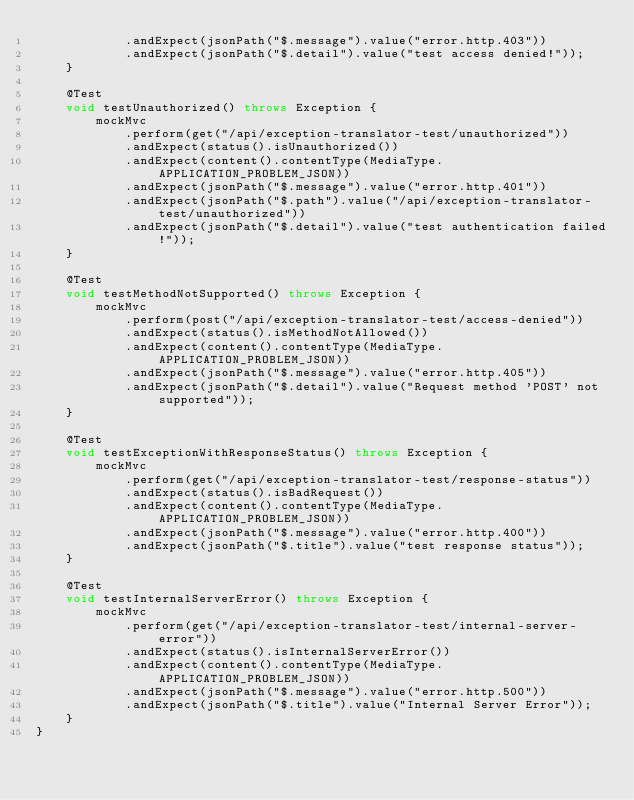Convert code to text. <code><loc_0><loc_0><loc_500><loc_500><_Java_>            .andExpect(jsonPath("$.message").value("error.http.403"))
            .andExpect(jsonPath("$.detail").value("test access denied!"));
    }

    @Test
    void testUnauthorized() throws Exception {
        mockMvc
            .perform(get("/api/exception-translator-test/unauthorized"))
            .andExpect(status().isUnauthorized())
            .andExpect(content().contentType(MediaType.APPLICATION_PROBLEM_JSON))
            .andExpect(jsonPath("$.message").value("error.http.401"))
            .andExpect(jsonPath("$.path").value("/api/exception-translator-test/unauthorized"))
            .andExpect(jsonPath("$.detail").value("test authentication failed!"));
    }

    @Test
    void testMethodNotSupported() throws Exception {
        mockMvc
            .perform(post("/api/exception-translator-test/access-denied"))
            .andExpect(status().isMethodNotAllowed())
            .andExpect(content().contentType(MediaType.APPLICATION_PROBLEM_JSON))
            .andExpect(jsonPath("$.message").value("error.http.405"))
            .andExpect(jsonPath("$.detail").value("Request method 'POST' not supported"));
    }

    @Test
    void testExceptionWithResponseStatus() throws Exception {
        mockMvc
            .perform(get("/api/exception-translator-test/response-status"))
            .andExpect(status().isBadRequest())
            .andExpect(content().contentType(MediaType.APPLICATION_PROBLEM_JSON))
            .andExpect(jsonPath("$.message").value("error.http.400"))
            .andExpect(jsonPath("$.title").value("test response status"));
    }

    @Test
    void testInternalServerError() throws Exception {
        mockMvc
            .perform(get("/api/exception-translator-test/internal-server-error"))
            .andExpect(status().isInternalServerError())
            .andExpect(content().contentType(MediaType.APPLICATION_PROBLEM_JSON))
            .andExpect(jsonPath("$.message").value("error.http.500"))
            .andExpect(jsonPath("$.title").value("Internal Server Error"));
    }
}
</code> 